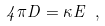<formula> <loc_0><loc_0><loc_500><loc_500>4 \pi D = \kappa E \ ,</formula> 